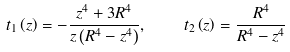Convert formula to latex. <formula><loc_0><loc_0><loc_500><loc_500>t _ { 1 } \left ( z \right ) = - \frac { z ^ { 4 } + 3 R ^ { 4 } } { z \left ( R ^ { 4 } - z ^ { 4 } \right ) } , \quad t _ { 2 } \left ( z \right ) = \frac { R ^ { 4 } } { R ^ { 4 } - z ^ { 4 } }</formula> 